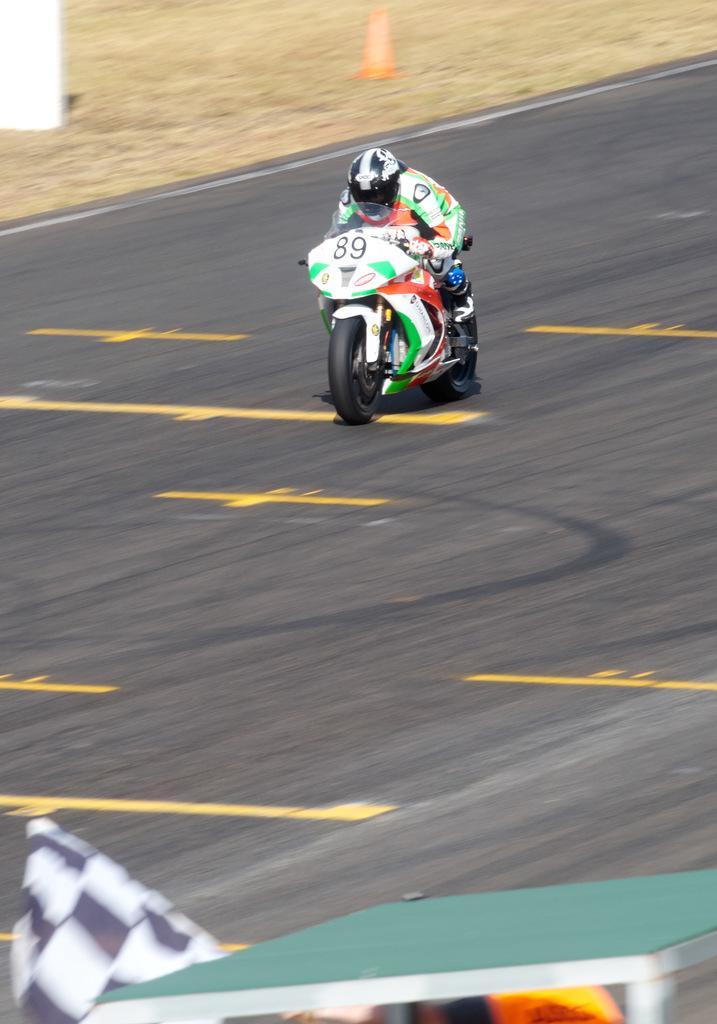Can you describe this image briefly? In this image I can see the person riding the motorbike. The person is wearing the colorful dress and helmet. To the side of the road I can see the traffic cone and the ground but it is blurry. 